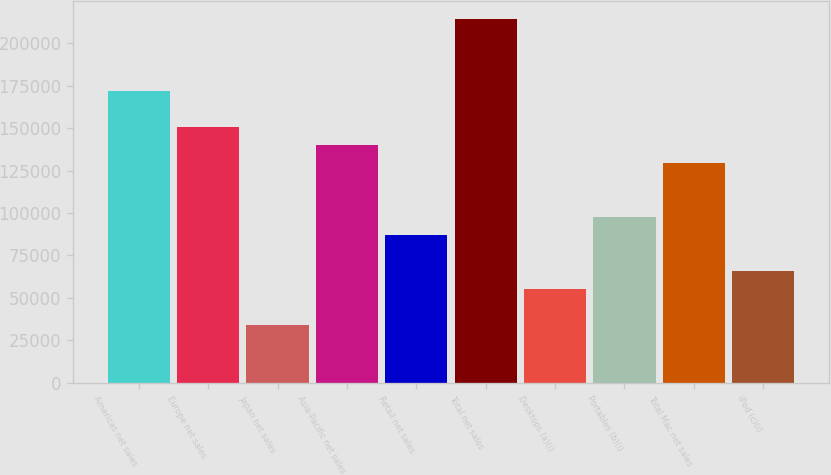<chart> <loc_0><loc_0><loc_500><loc_500><bar_chart><fcel>Americas net sales<fcel>Europe net sales<fcel>Japan net sales<fcel>Asia-Pacific net sales<fcel>Retail net sales<fcel>Total net sales<fcel>Desktops (a)(i)<fcel>Portables (b)(i)<fcel>Total Mac net sales<fcel>iPod (c)(i)<nl><fcel>171800<fcel>150617<fcel>34105.7<fcel>140025<fcel>87065.2<fcel>214168<fcel>55289.5<fcel>97657.1<fcel>129433<fcel>65881.4<nl></chart> 